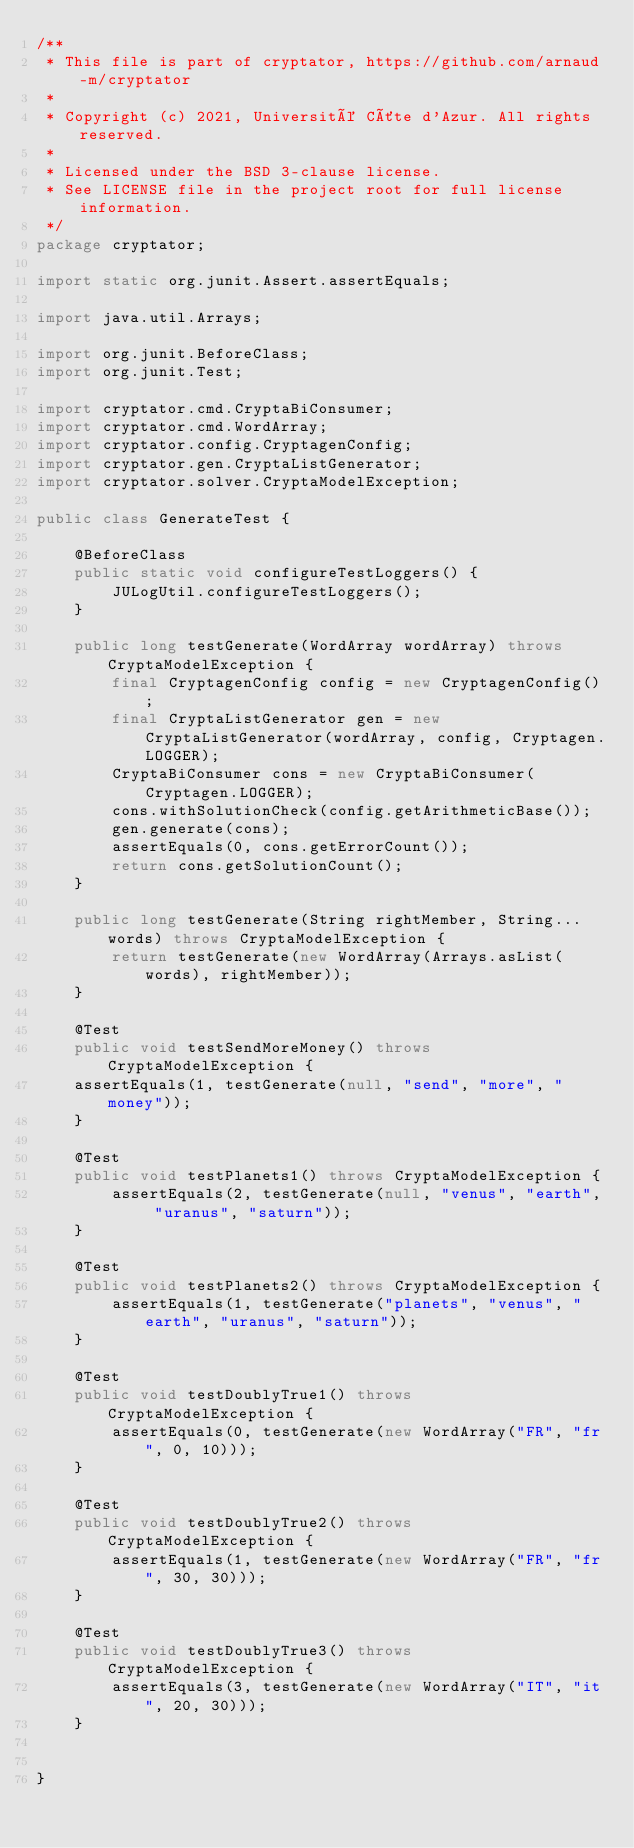<code> <loc_0><loc_0><loc_500><loc_500><_Java_>/**
 * This file is part of cryptator, https://github.com/arnaud-m/cryptator
 *
 * Copyright (c) 2021, Université Côte d'Azur. All rights reserved.
 *
 * Licensed under the BSD 3-clause license.
 * See LICENSE file in the project root for full license information.
 */
package cryptator;

import static org.junit.Assert.assertEquals;

import java.util.Arrays;

import org.junit.BeforeClass;
import org.junit.Test;

import cryptator.cmd.CryptaBiConsumer;
import cryptator.cmd.WordArray;
import cryptator.config.CryptagenConfig;
import cryptator.gen.CryptaListGenerator;
import cryptator.solver.CryptaModelException;

public class GenerateTest {

	@BeforeClass
	public static void configureTestLoggers() {
		JULogUtil.configureTestLoggers();
	}
	
	public long testGenerate(WordArray wordArray) throws CryptaModelException {
		final CryptagenConfig config = new CryptagenConfig();
		final CryptaListGenerator gen = new CryptaListGenerator(wordArray, config, Cryptagen.LOGGER);
		CryptaBiConsumer cons = new CryptaBiConsumer(Cryptagen.LOGGER);
		cons.withSolutionCheck(config.getArithmeticBase());
		gen.generate(cons);
		assertEquals(0, cons.getErrorCount());
		return cons.getSolutionCount();
	}
	
	public long testGenerate(String rightMember, String... words) throws CryptaModelException {
		return testGenerate(new WordArray(Arrays.asList(words), rightMember));
	}
	
	@Test
	public void testSendMoreMoney() throws CryptaModelException {
	assertEquals(1, testGenerate(null, "send", "more", "money"));
	}
	
	@Test
	public void testPlanets1() throws CryptaModelException {
		assertEquals(2, testGenerate(null, "venus", "earth", "uranus", "saturn"));
	}
	
	@Test
	public void testPlanets2() throws CryptaModelException {
		assertEquals(1, testGenerate("planets", "venus", "earth", "uranus", "saturn"));
	}
	
	@Test
	public void testDoublyTrue1() throws CryptaModelException {
		assertEquals(0, testGenerate(new WordArray("FR", "fr", 0, 10)));
	}
	
	@Test
	public void testDoublyTrue2() throws CryptaModelException {
		assertEquals(1, testGenerate(new WordArray("FR", "fr", 30, 30)));
	}
	
	@Test
	public void testDoublyTrue3() throws CryptaModelException {
		assertEquals(3, testGenerate(new WordArray("IT", "it", 20, 30)));
	}
	
	
}
</code> 